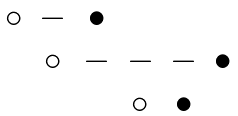Convert formula to latex. <formula><loc_0><loc_0><loc_500><loc_500>\begin{matrix} \circ & - & \bullet & & & \\ & \circ & - & - & - & \bullet \\ & & & \circ & \bullet & \\ \end{matrix}</formula> 